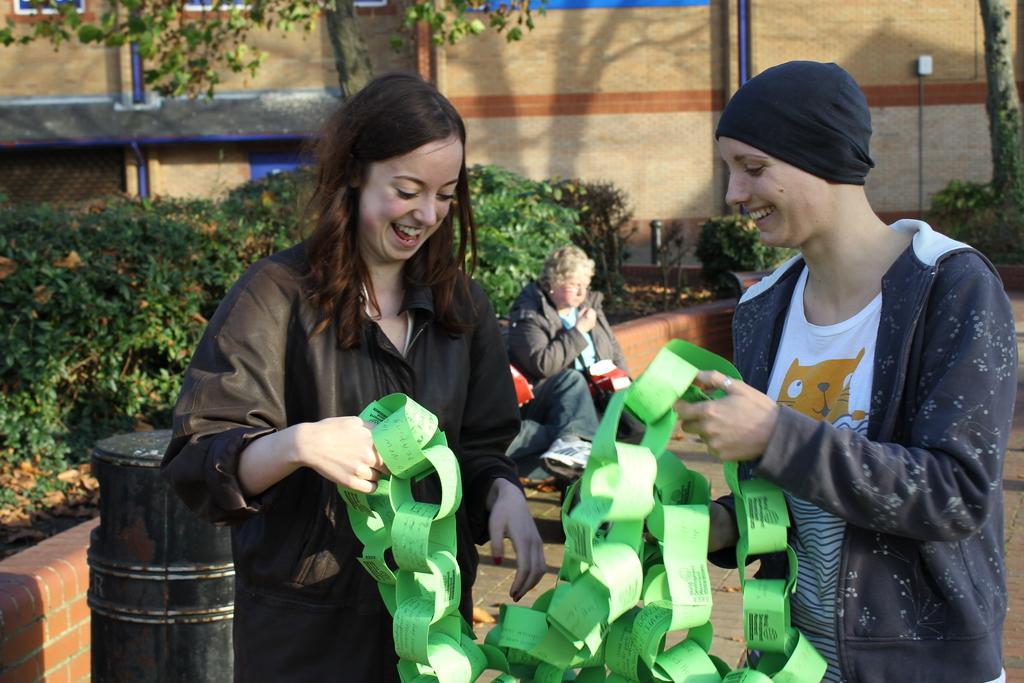In one or two sentences, can you explain what this image depicts? In this image we can see two women holding the list of some papers. On the backside we can see a woman sitting, a container, a fence, a group of plants, trees and a wall. 